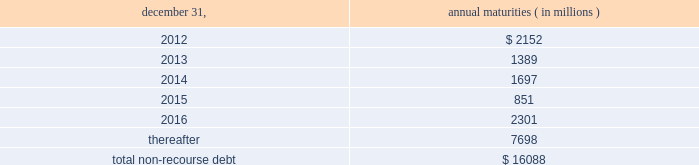The aes corporation notes to consolidated financial statements 2014 ( continued ) december 31 , 2011 , 2010 , and 2009 ( 1 ) weighted average interest rate at december 31 , 2011 .
( 2 ) the company has interest rate swaps and interest rate option agreements in an aggregate notional principal amount of approximately $ 3.6 billion on non-recourse debt outstanding at december 31 , 2011 .
The swap agreements economically change the variable interest rates on the portion of the debt covered by the notional amounts to fixed rates ranging from approximately 1.44% ( 1.44 % ) to 6.98% ( 6.98 % ) .
The option agreements fix interest rates within a range from 1.00% ( 1.00 % ) to 7.00% ( 7.00 % ) .
The agreements expire at various dates from 2016 through 2028 .
( 3 ) multilateral loans include loans funded and guaranteed by bilaterals , multilaterals , development banks and other similar institutions .
( 4 ) non-recourse debt of $ 704 million and $ 945 million as of december 31 , 2011 and 2010 , respectively , was excluded from non-recourse debt and included in current and long-term liabilities of held for sale and discontinued businesses in the accompanying consolidated balance sheets .
Non-recourse debt as of december 31 , 2011 is scheduled to reach maturity as set forth in the table below : december 31 , annual maturities ( in millions ) .
As of december 31 , 2011 , aes subsidiaries with facilities under construction had a total of approximately $ 1.4 billion of committed but unused credit facilities available to fund construction and other related costs .
Excluding these facilities under construction , aes subsidiaries had approximately $ 1.2 billion in a number of available but unused committed revolving credit lines to support their working capital , debt service reserves and other business needs .
These credit lines can be used in one or more of the following ways : solely for borrowings ; solely for letters of credit ; or a combination of these uses .
The weighted average interest rate on borrowings from these facilities was 14.75% ( 14.75 % ) at december 31 , 2011 .
On october 3 , 2011 , dolphin subsidiary ii , inc .
( 201cdolphin ii 201d ) , a newly formed , wholly-owned special purpose indirect subsidiary of aes , entered into an indenture ( the 201cindenture 201d ) with wells fargo bank , n.a .
( the 201ctrustee 201d ) as part of its issuance of $ 450 million aggregate principal amount of 6.50% ( 6.50 % ) senior notes due 2016 ( the 201c2016 notes 201d ) and $ 800 million aggregate principal amount of 7.25% ( 7.25 % ) senior notes due 2021 ( the 201c7.25% ( 201c7.25 % ) 2021 notes 201d , together with the 2016 notes , the 201cnotes 201d ) to finance the acquisition ( the 201cacquisition 201d ) of dpl .
Upon closing of the acquisition on november 28 , 2011 , dolphin ii was merged into dpl with dpl being the surviving entity and obligor .
The 2016 notes and the 7.25% ( 7.25 % ) 2021 notes are included under 201cnotes and bonds 201d in the non-recourse detail table above .
See note 23 2014acquisitions and dispositions for further information .
Interest on the 2016 notes and the 7.25% ( 7.25 % ) 2021 notes accrues at a rate of 6.50% ( 6.50 % ) and 7.25% ( 7.25 % ) per year , respectively , and is payable on april 15 and october 15 of each year , beginning april 15 , 2012 .
Prior to september 15 , 2016 with respect to the 2016 notes and july 15 , 2021 with respect to the 7.25% ( 7.25 % ) 2021 notes , dpl may redeem some or all of the 2016 notes or 7.25% ( 7.25 % ) 2021 notes at par , plus a 201cmake-whole 201d amount set forth in .
What percentage of lt debt is due in greater than 5 years?\\n? 
Computations: (7698 / 16088)
Answer: 0.47849. 